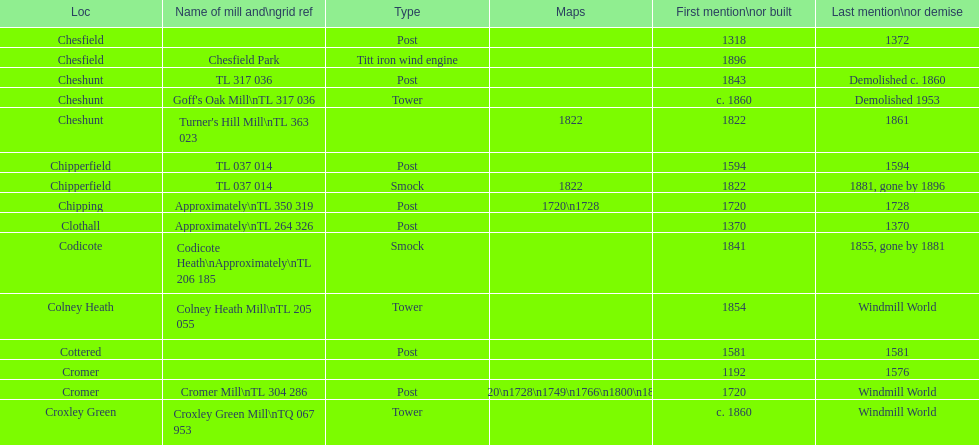How many mills were mentioned or built before 1700? 5. 